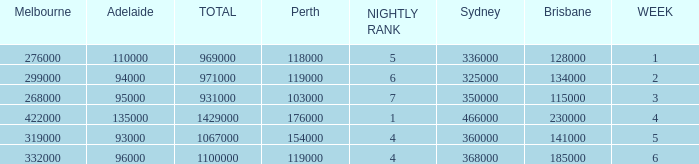What was the rating for Brisbane the week that Adelaide had 94000? 134000.0. 